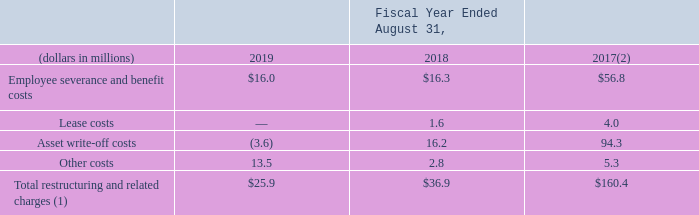Restructuring and Related Charges
Following is a summary of our restructuring and related charges:
(1) Includes $21.5 million, $16.3 million and $51.3 million recorded in the EMS segment, $2.6 million, $16.6 million and $82.4 million recorded in the DMS segment and $1.8 million, $4.0 million and $26.7 million of non-allocated charges for the fiscal years ended August 31, 2019, 2018 and 2017, respectively. Except for asset write-off costs, all restructuring and related charges are cash settled.
(2) Fiscal year ended August 31, 2017, includes expenses related to the 2017 and 2013 Restructuring Plans.
How much was of total restructuring and related charges was recorded in the EMS segment in 2019? $21.5 million. What were the Employee severance and benefit costs in 2018?
Answer scale should be: million. $16.3. Which years of Restructuring Plans did the fiscal year ended August 31, 2017 include expenses related to? 2017, 2013. What was the change in Employee severance and benefit costs between 2018 and 2019?
Answer scale should be: million. $16.0-$16.3
Answer: -0.3. How many years did Total restructuring and related charges exceed $100 million? 2017
Answer: 1. What was the percentage change in other costs between 2018 and 2019?
Answer scale should be: percent. (13.5-2.8)/2.8
Answer: 382.14. 